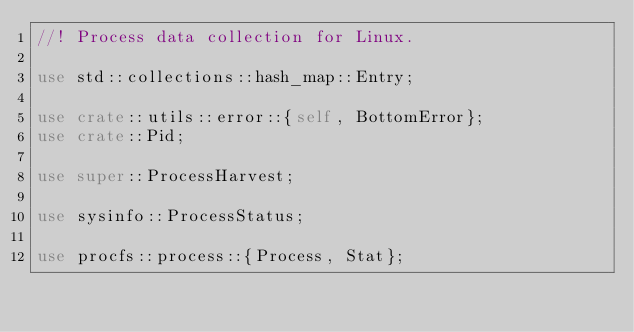<code> <loc_0><loc_0><loc_500><loc_500><_Rust_>//! Process data collection for Linux.

use std::collections::hash_map::Entry;

use crate::utils::error::{self, BottomError};
use crate::Pid;

use super::ProcessHarvest;

use sysinfo::ProcessStatus;

use procfs::process::{Process, Stat};
</code> 